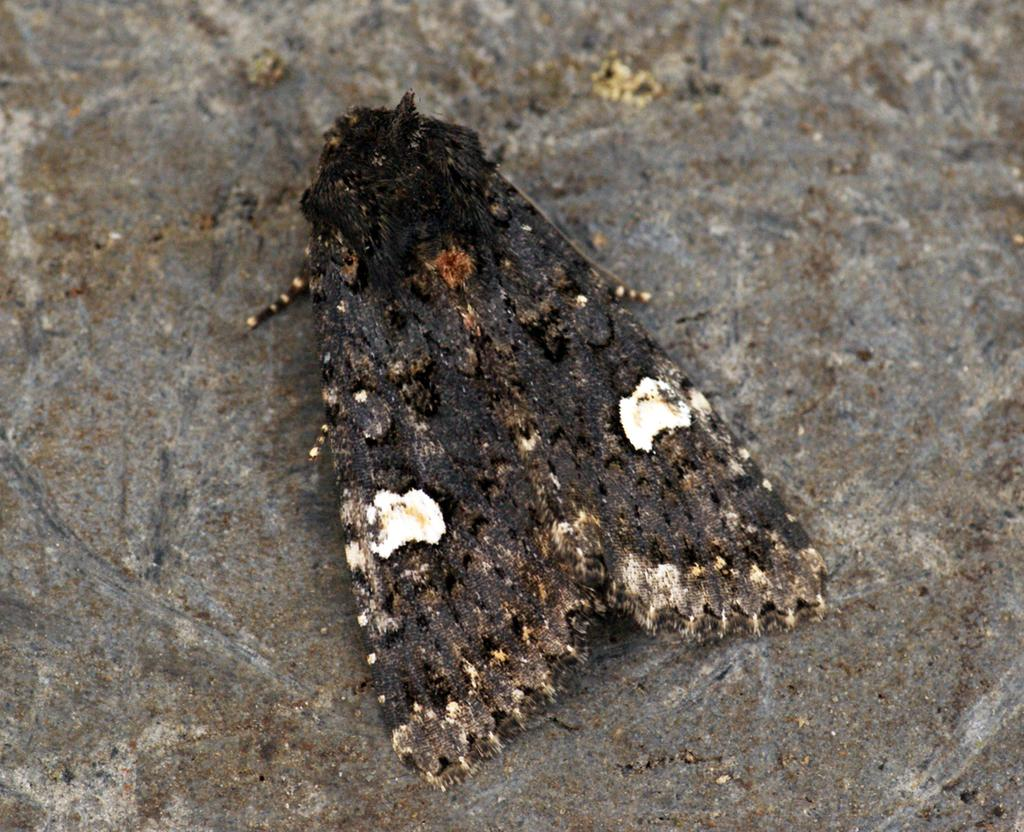What type of creature is in the image? There is an insect in the image. What color is the insect? The insect is black in color. Where is the insect located in the image? The insect is on the road. What type of dish is the insect cooking on the island in the image? There is no dish or island present in the image; it only features an insect on the road. 